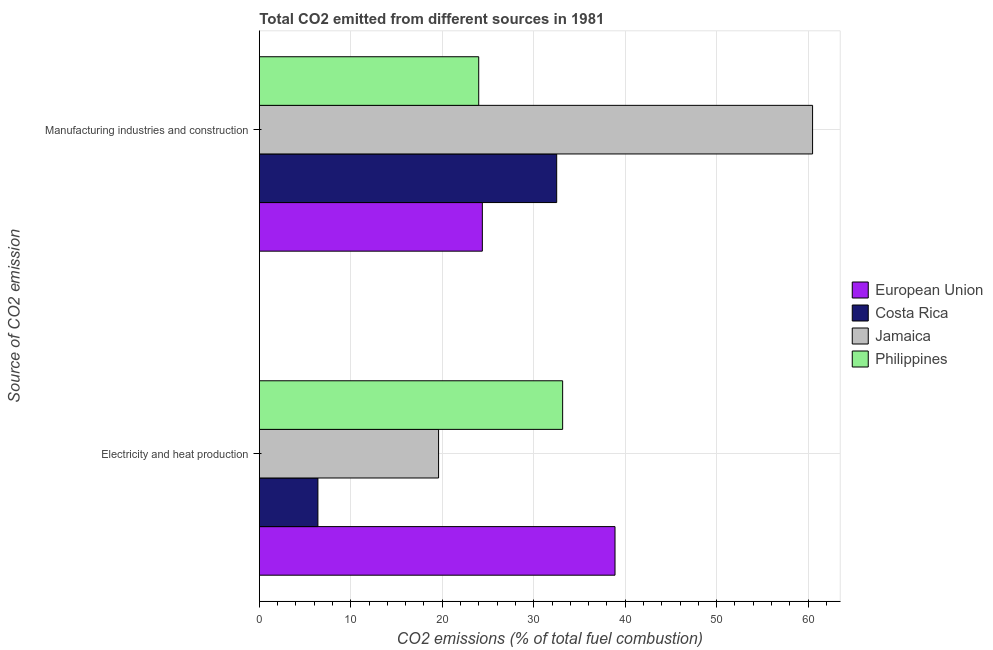How many groups of bars are there?
Your response must be concise. 2. What is the label of the 1st group of bars from the top?
Your response must be concise. Manufacturing industries and construction. What is the co2 emissions due to electricity and heat production in Philippines?
Give a very brief answer. 33.16. Across all countries, what is the maximum co2 emissions due to manufacturing industries?
Give a very brief answer. 60.49. Across all countries, what is the minimum co2 emissions due to electricity and heat production?
Provide a succinct answer. 6.4. In which country was the co2 emissions due to manufacturing industries maximum?
Provide a succinct answer. Jamaica. In which country was the co2 emissions due to manufacturing industries minimum?
Ensure brevity in your answer.  Philippines. What is the total co2 emissions due to manufacturing industries in the graph?
Provide a short and direct response. 141.38. What is the difference between the co2 emissions due to manufacturing industries in European Union and that in Jamaica?
Ensure brevity in your answer.  -36.11. What is the difference between the co2 emissions due to manufacturing industries in Philippines and the co2 emissions due to electricity and heat production in Costa Rica?
Your answer should be compact. 17.58. What is the average co2 emissions due to electricity and heat production per country?
Your answer should be very brief. 24.51. What is the difference between the co2 emissions due to electricity and heat production and co2 emissions due to manufacturing industries in Philippines?
Keep it short and to the point. 9.18. In how many countries, is the co2 emissions due to electricity and heat production greater than 10 %?
Offer a very short reply. 3. What is the ratio of the co2 emissions due to electricity and heat production in Philippines to that in Jamaica?
Keep it short and to the point. 1.69. In how many countries, is the co2 emissions due to manufacturing industries greater than the average co2 emissions due to manufacturing industries taken over all countries?
Ensure brevity in your answer.  1. What is the difference between two consecutive major ticks on the X-axis?
Give a very brief answer. 10. Are the values on the major ticks of X-axis written in scientific E-notation?
Provide a succinct answer. No. How many legend labels are there?
Your answer should be compact. 4. How are the legend labels stacked?
Give a very brief answer. Vertical. What is the title of the graph?
Make the answer very short. Total CO2 emitted from different sources in 1981. Does "Dominica" appear as one of the legend labels in the graph?
Your response must be concise. No. What is the label or title of the X-axis?
Give a very brief answer. CO2 emissions (% of total fuel combustion). What is the label or title of the Y-axis?
Offer a terse response. Source of CO2 emission. What is the CO2 emissions (% of total fuel combustion) of European Union in Electricity and heat production?
Provide a short and direct response. 38.89. What is the CO2 emissions (% of total fuel combustion) of Costa Rica in Electricity and heat production?
Your answer should be very brief. 6.4. What is the CO2 emissions (% of total fuel combustion) in Jamaica in Electricity and heat production?
Offer a terse response. 19.6. What is the CO2 emissions (% of total fuel combustion) in Philippines in Electricity and heat production?
Ensure brevity in your answer.  33.16. What is the CO2 emissions (% of total fuel combustion) in European Union in Manufacturing industries and construction?
Your answer should be compact. 24.38. What is the CO2 emissions (% of total fuel combustion) in Costa Rica in Manufacturing industries and construction?
Give a very brief answer. 32.51. What is the CO2 emissions (% of total fuel combustion) in Jamaica in Manufacturing industries and construction?
Keep it short and to the point. 60.49. What is the CO2 emissions (% of total fuel combustion) in Philippines in Manufacturing industries and construction?
Make the answer very short. 23.99. Across all Source of CO2 emission, what is the maximum CO2 emissions (% of total fuel combustion) of European Union?
Provide a short and direct response. 38.89. Across all Source of CO2 emission, what is the maximum CO2 emissions (% of total fuel combustion) of Costa Rica?
Your response must be concise. 32.51. Across all Source of CO2 emission, what is the maximum CO2 emissions (% of total fuel combustion) in Jamaica?
Your answer should be compact. 60.49. Across all Source of CO2 emission, what is the maximum CO2 emissions (% of total fuel combustion) in Philippines?
Ensure brevity in your answer.  33.16. Across all Source of CO2 emission, what is the minimum CO2 emissions (% of total fuel combustion) in European Union?
Provide a short and direct response. 24.38. Across all Source of CO2 emission, what is the minimum CO2 emissions (% of total fuel combustion) in Costa Rica?
Make the answer very short. 6.4. Across all Source of CO2 emission, what is the minimum CO2 emissions (% of total fuel combustion) in Jamaica?
Your answer should be compact. 19.6. Across all Source of CO2 emission, what is the minimum CO2 emissions (% of total fuel combustion) in Philippines?
Keep it short and to the point. 23.99. What is the total CO2 emissions (% of total fuel combustion) in European Union in the graph?
Your answer should be compact. 63.27. What is the total CO2 emissions (% of total fuel combustion) of Costa Rica in the graph?
Keep it short and to the point. 38.92. What is the total CO2 emissions (% of total fuel combustion) of Jamaica in the graph?
Offer a very short reply. 80.09. What is the total CO2 emissions (% of total fuel combustion) of Philippines in the graph?
Provide a short and direct response. 57.15. What is the difference between the CO2 emissions (% of total fuel combustion) of European Union in Electricity and heat production and that in Manufacturing industries and construction?
Ensure brevity in your answer.  14.51. What is the difference between the CO2 emissions (% of total fuel combustion) of Costa Rica in Electricity and heat production and that in Manufacturing industries and construction?
Give a very brief answer. -26.11. What is the difference between the CO2 emissions (% of total fuel combustion) in Jamaica in Electricity and heat production and that in Manufacturing industries and construction?
Keep it short and to the point. -40.9. What is the difference between the CO2 emissions (% of total fuel combustion) in Philippines in Electricity and heat production and that in Manufacturing industries and construction?
Offer a very short reply. 9.18. What is the difference between the CO2 emissions (% of total fuel combustion) of European Union in Electricity and heat production and the CO2 emissions (% of total fuel combustion) of Costa Rica in Manufacturing industries and construction?
Offer a very short reply. 6.38. What is the difference between the CO2 emissions (% of total fuel combustion) of European Union in Electricity and heat production and the CO2 emissions (% of total fuel combustion) of Jamaica in Manufacturing industries and construction?
Provide a short and direct response. -21.6. What is the difference between the CO2 emissions (% of total fuel combustion) in European Union in Electricity and heat production and the CO2 emissions (% of total fuel combustion) in Philippines in Manufacturing industries and construction?
Make the answer very short. 14.9. What is the difference between the CO2 emissions (% of total fuel combustion) of Costa Rica in Electricity and heat production and the CO2 emissions (% of total fuel combustion) of Jamaica in Manufacturing industries and construction?
Make the answer very short. -54.09. What is the difference between the CO2 emissions (% of total fuel combustion) of Costa Rica in Electricity and heat production and the CO2 emissions (% of total fuel combustion) of Philippines in Manufacturing industries and construction?
Make the answer very short. -17.58. What is the difference between the CO2 emissions (% of total fuel combustion) of Jamaica in Electricity and heat production and the CO2 emissions (% of total fuel combustion) of Philippines in Manufacturing industries and construction?
Offer a very short reply. -4.39. What is the average CO2 emissions (% of total fuel combustion) in European Union per Source of CO2 emission?
Offer a very short reply. 31.64. What is the average CO2 emissions (% of total fuel combustion) of Costa Rica per Source of CO2 emission?
Give a very brief answer. 19.46. What is the average CO2 emissions (% of total fuel combustion) of Jamaica per Source of CO2 emission?
Ensure brevity in your answer.  40.05. What is the average CO2 emissions (% of total fuel combustion) of Philippines per Source of CO2 emission?
Your answer should be very brief. 28.58. What is the difference between the CO2 emissions (% of total fuel combustion) in European Union and CO2 emissions (% of total fuel combustion) in Costa Rica in Electricity and heat production?
Offer a very short reply. 32.49. What is the difference between the CO2 emissions (% of total fuel combustion) in European Union and CO2 emissions (% of total fuel combustion) in Jamaica in Electricity and heat production?
Provide a succinct answer. 19.29. What is the difference between the CO2 emissions (% of total fuel combustion) of European Union and CO2 emissions (% of total fuel combustion) of Philippines in Electricity and heat production?
Provide a short and direct response. 5.73. What is the difference between the CO2 emissions (% of total fuel combustion) in Costa Rica and CO2 emissions (% of total fuel combustion) in Jamaica in Electricity and heat production?
Ensure brevity in your answer.  -13.19. What is the difference between the CO2 emissions (% of total fuel combustion) of Costa Rica and CO2 emissions (% of total fuel combustion) of Philippines in Electricity and heat production?
Make the answer very short. -26.76. What is the difference between the CO2 emissions (% of total fuel combustion) of Jamaica and CO2 emissions (% of total fuel combustion) of Philippines in Electricity and heat production?
Provide a short and direct response. -13.57. What is the difference between the CO2 emissions (% of total fuel combustion) of European Union and CO2 emissions (% of total fuel combustion) of Costa Rica in Manufacturing industries and construction?
Provide a succinct answer. -8.13. What is the difference between the CO2 emissions (% of total fuel combustion) of European Union and CO2 emissions (% of total fuel combustion) of Jamaica in Manufacturing industries and construction?
Ensure brevity in your answer.  -36.11. What is the difference between the CO2 emissions (% of total fuel combustion) of European Union and CO2 emissions (% of total fuel combustion) of Philippines in Manufacturing industries and construction?
Provide a short and direct response. 0.4. What is the difference between the CO2 emissions (% of total fuel combustion) in Costa Rica and CO2 emissions (% of total fuel combustion) in Jamaica in Manufacturing industries and construction?
Provide a short and direct response. -27.98. What is the difference between the CO2 emissions (% of total fuel combustion) in Costa Rica and CO2 emissions (% of total fuel combustion) in Philippines in Manufacturing industries and construction?
Keep it short and to the point. 8.53. What is the difference between the CO2 emissions (% of total fuel combustion) of Jamaica and CO2 emissions (% of total fuel combustion) of Philippines in Manufacturing industries and construction?
Provide a succinct answer. 36.51. What is the ratio of the CO2 emissions (% of total fuel combustion) of European Union in Electricity and heat production to that in Manufacturing industries and construction?
Provide a short and direct response. 1.59. What is the ratio of the CO2 emissions (% of total fuel combustion) of Costa Rica in Electricity and heat production to that in Manufacturing industries and construction?
Offer a terse response. 0.2. What is the ratio of the CO2 emissions (% of total fuel combustion) in Jamaica in Electricity and heat production to that in Manufacturing industries and construction?
Provide a succinct answer. 0.32. What is the ratio of the CO2 emissions (% of total fuel combustion) in Philippines in Electricity and heat production to that in Manufacturing industries and construction?
Keep it short and to the point. 1.38. What is the difference between the highest and the second highest CO2 emissions (% of total fuel combustion) of European Union?
Your response must be concise. 14.51. What is the difference between the highest and the second highest CO2 emissions (% of total fuel combustion) of Costa Rica?
Offer a terse response. 26.11. What is the difference between the highest and the second highest CO2 emissions (% of total fuel combustion) of Jamaica?
Your answer should be very brief. 40.9. What is the difference between the highest and the second highest CO2 emissions (% of total fuel combustion) in Philippines?
Make the answer very short. 9.18. What is the difference between the highest and the lowest CO2 emissions (% of total fuel combustion) of European Union?
Provide a succinct answer. 14.51. What is the difference between the highest and the lowest CO2 emissions (% of total fuel combustion) of Costa Rica?
Your response must be concise. 26.11. What is the difference between the highest and the lowest CO2 emissions (% of total fuel combustion) in Jamaica?
Make the answer very short. 40.9. What is the difference between the highest and the lowest CO2 emissions (% of total fuel combustion) in Philippines?
Provide a succinct answer. 9.18. 